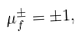Convert formula to latex. <formula><loc_0><loc_0><loc_500><loc_500>\mu _ { f } ^ { \pm } = \pm 1 ,</formula> 